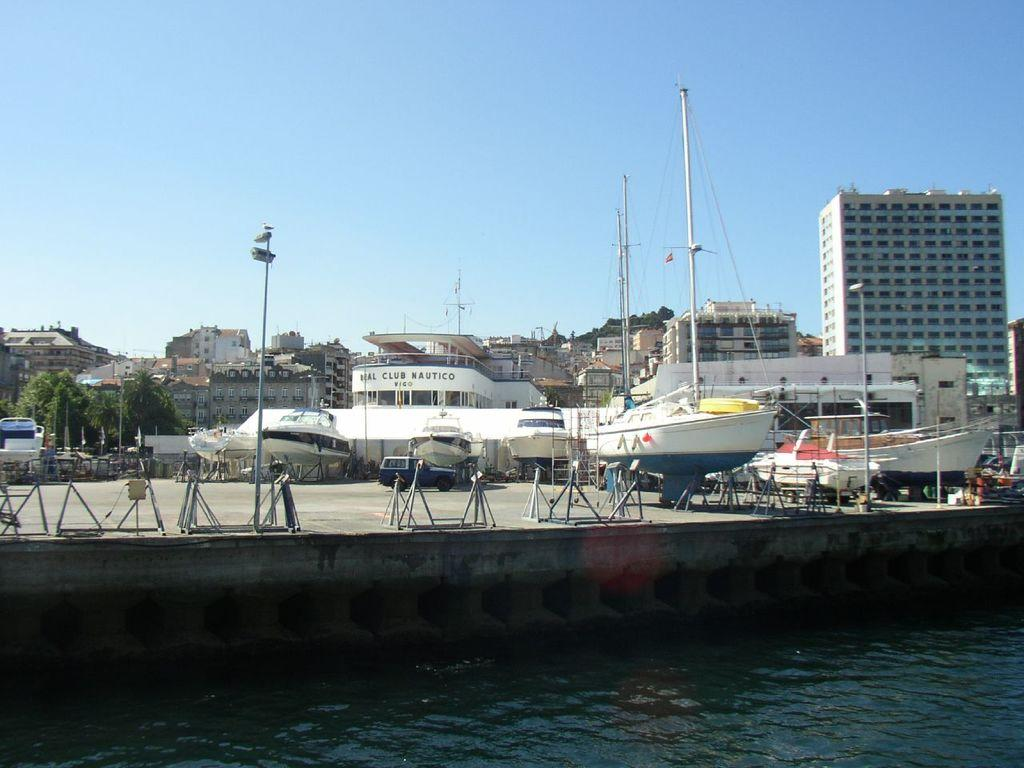What is at the bottom of the image? There is water at the bottom of the image. What can be seen in the middle of the image? There are boats in the middle of the image. What type of vegetation is at the back side of the image? There are trees at the back side of the image. What structures are at the back side of the image? There are buildings at the back side of the image. What is visible at the top of the image? The sky is visible at the top of the image. What type of sleet can be seen falling from the sky in the image? There is no sleet present in the image; it only shows water, boats, trees, buildings, and the sky. What is the quiver used for in the image? There is no quiver present in the image, so it cannot be used for anything. 